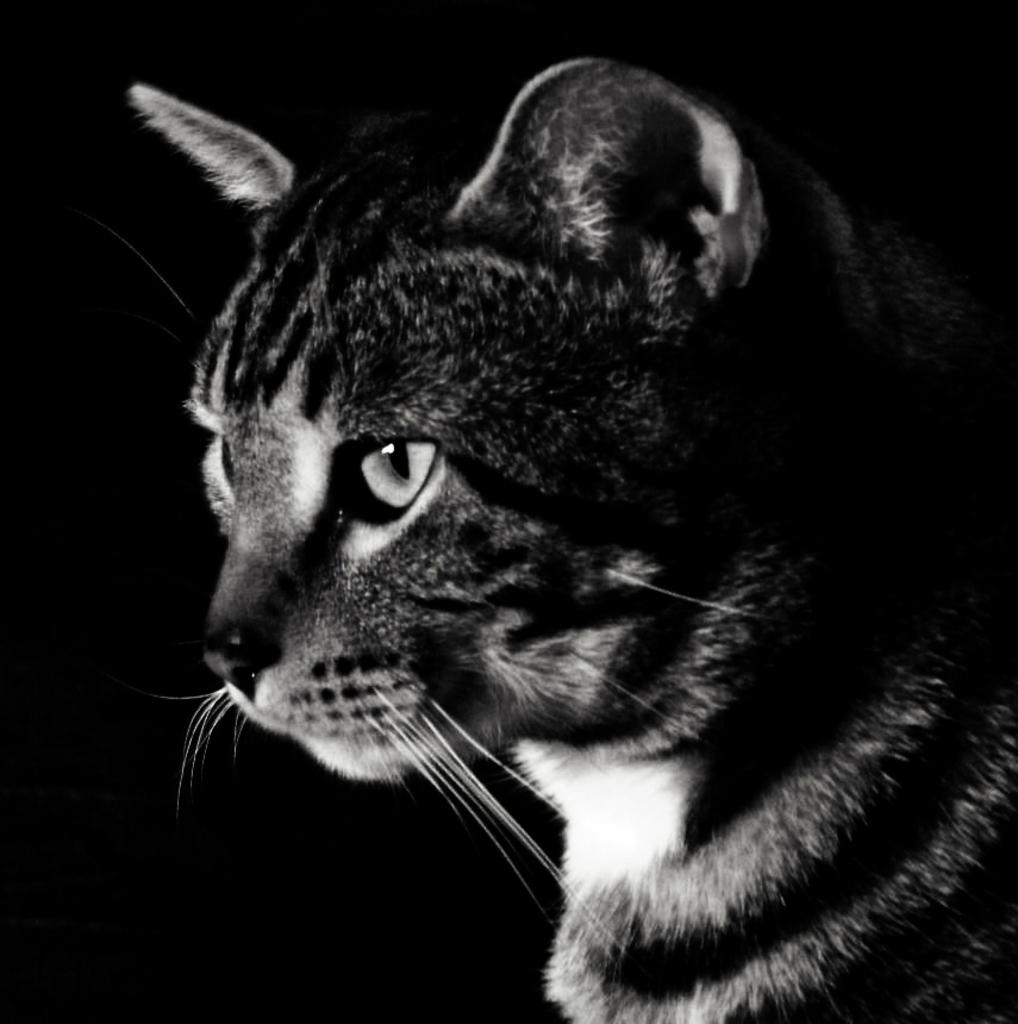What type of animal is in the image? There is a cat in the image. What color is the background of the image? The background of the image is black. How many chairs are visible in the image? There are no chairs present in the image; it only features a cat and a black background. 